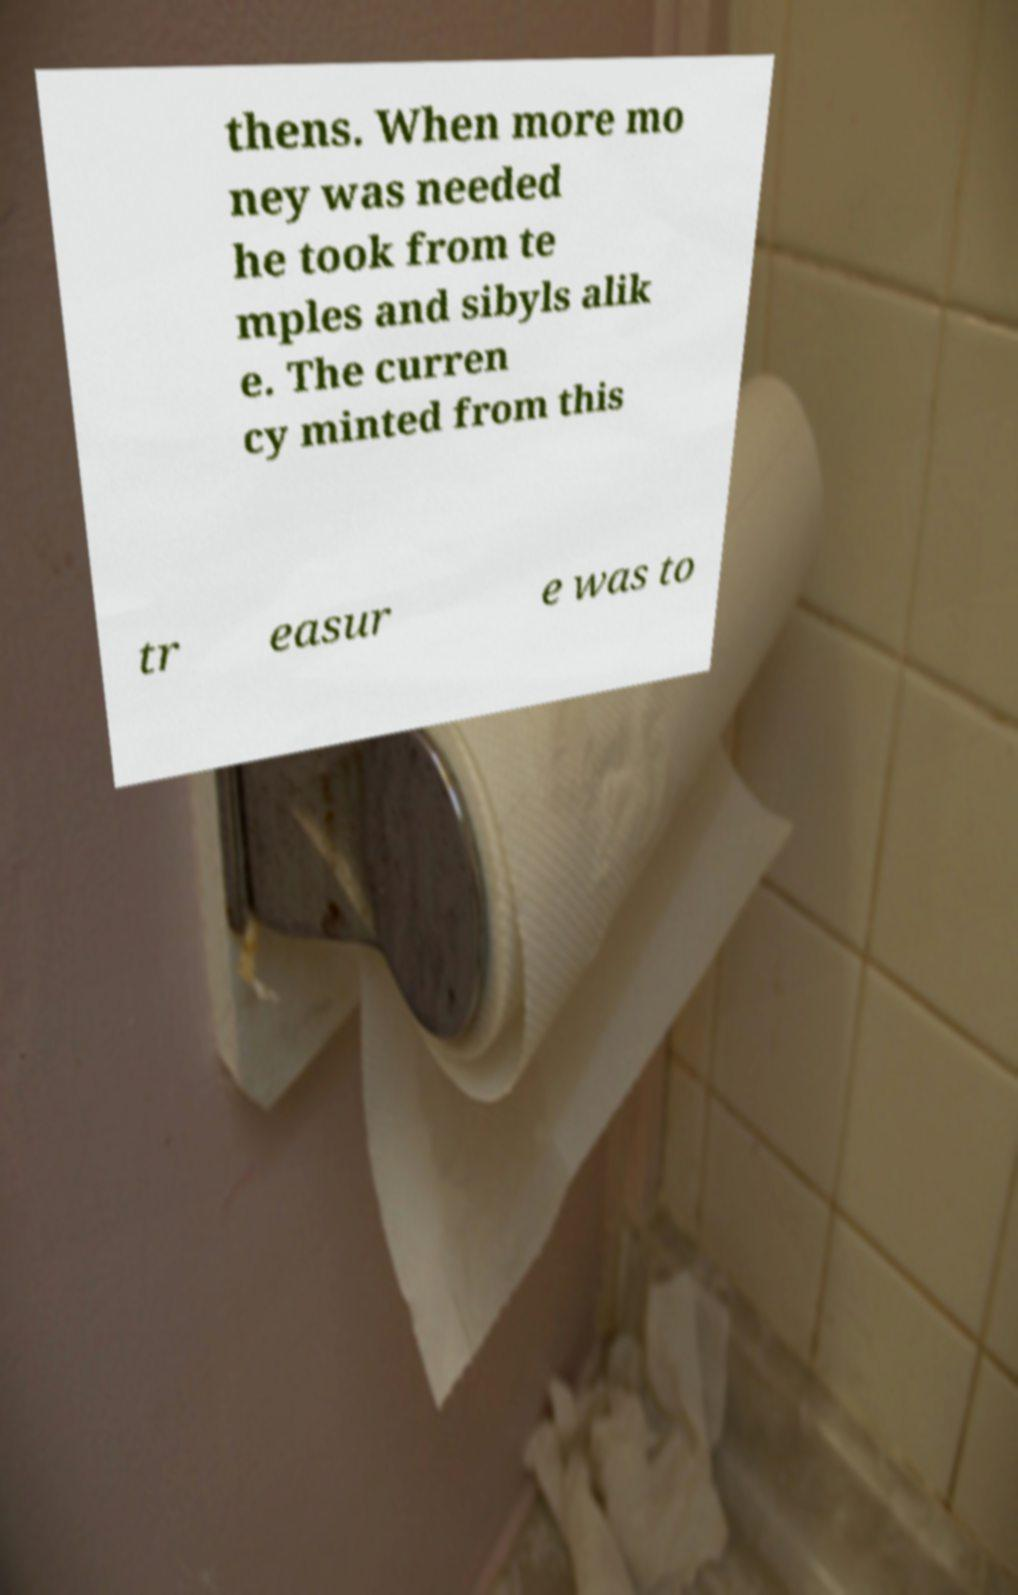Can you read and provide the text displayed in the image?This photo seems to have some interesting text. Can you extract and type it out for me? thens. When more mo ney was needed he took from te mples and sibyls alik e. The curren cy minted from this tr easur e was to 